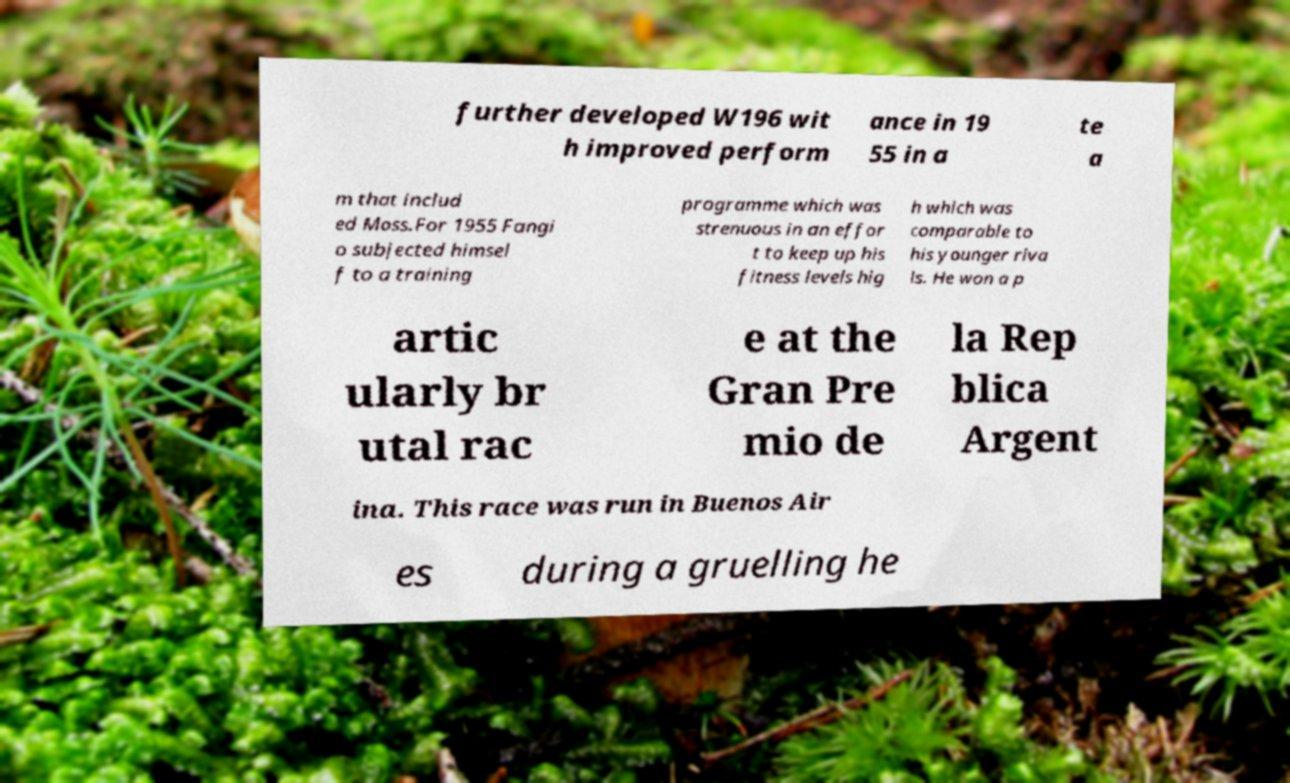There's text embedded in this image that I need extracted. Can you transcribe it verbatim? further developed W196 wit h improved perform ance in 19 55 in a te a m that includ ed Moss.For 1955 Fangi o subjected himsel f to a training programme which was strenuous in an effor t to keep up his fitness levels hig h which was comparable to his younger riva ls. He won a p artic ularly br utal rac e at the Gran Pre mio de la Rep blica Argent ina. This race was run in Buenos Air es during a gruelling he 